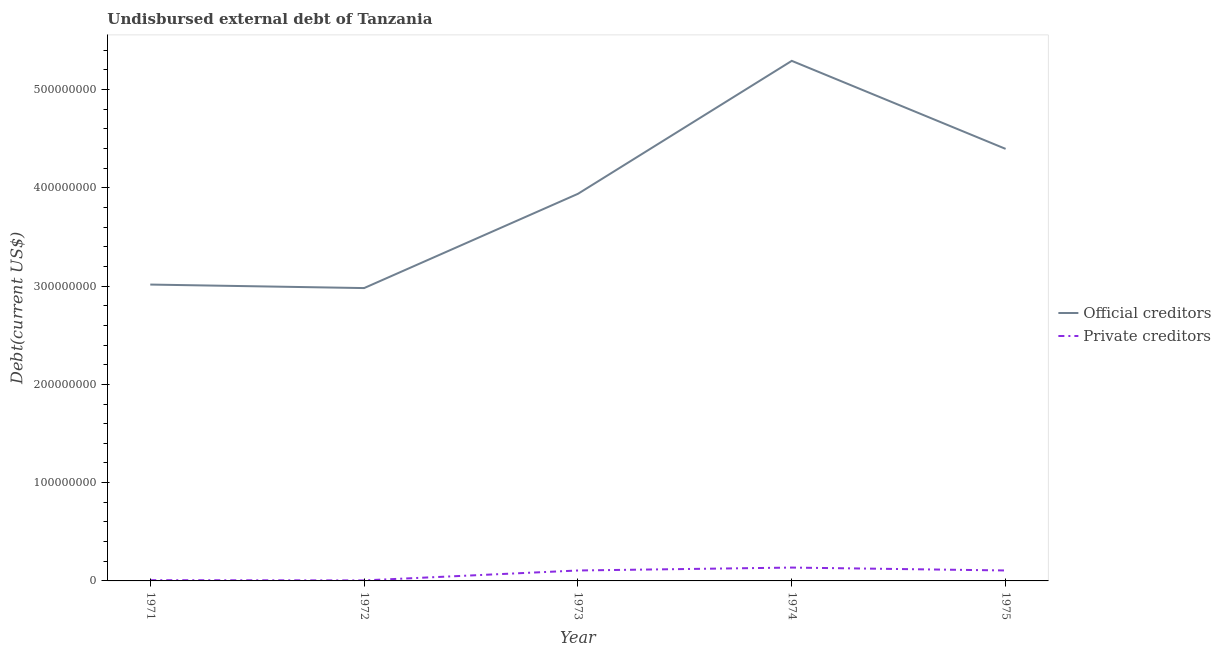How many different coloured lines are there?
Keep it short and to the point. 2. Does the line corresponding to undisbursed external debt of official creditors intersect with the line corresponding to undisbursed external debt of private creditors?
Your answer should be very brief. No. Is the number of lines equal to the number of legend labels?
Your response must be concise. Yes. What is the undisbursed external debt of official creditors in 1973?
Keep it short and to the point. 3.94e+08. Across all years, what is the maximum undisbursed external debt of official creditors?
Keep it short and to the point. 5.29e+08. Across all years, what is the minimum undisbursed external debt of private creditors?
Your answer should be very brief. 5.15e+05. In which year was the undisbursed external debt of private creditors maximum?
Provide a succinct answer. 1974. In which year was the undisbursed external debt of private creditors minimum?
Give a very brief answer. 1972. What is the total undisbursed external debt of official creditors in the graph?
Provide a short and direct response. 1.96e+09. What is the difference between the undisbursed external debt of private creditors in 1972 and that in 1973?
Ensure brevity in your answer.  -1.01e+07. What is the difference between the undisbursed external debt of official creditors in 1975 and the undisbursed external debt of private creditors in 1972?
Your response must be concise. 4.39e+08. What is the average undisbursed external debt of official creditors per year?
Your answer should be very brief. 3.92e+08. In the year 1972, what is the difference between the undisbursed external debt of official creditors and undisbursed external debt of private creditors?
Offer a terse response. 2.97e+08. In how many years, is the undisbursed external debt of private creditors greater than 340000000 US$?
Offer a terse response. 0. What is the ratio of the undisbursed external debt of official creditors in 1974 to that in 1975?
Provide a short and direct response. 1.2. Is the undisbursed external debt of official creditors in 1971 less than that in 1975?
Make the answer very short. Yes. Is the difference between the undisbursed external debt of official creditors in 1971 and 1975 greater than the difference between the undisbursed external debt of private creditors in 1971 and 1975?
Ensure brevity in your answer.  No. What is the difference between the highest and the second highest undisbursed external debt of official creditors?
Keep it short and to the point. 8.96e+07. What is the difference between the highest and the lowest undisbursed external debt of official creditors?
Your answer should be compact. 2.31e+08. Does the undisbursed external debt of official creditors monotonically increase over the years?
Make the answer very short. No. Is the undisbursed external debt of private creditors strictly less than the undisbursed external debt of official creditors over the years?
Your answer should be compact. Yes. How many years are there in the graph?
Your answer should be very brief. 5. What is the difference between two consecutive major ticks on the Y-axis?
Your answer should be very brief. 1.00e+08. Are the values on the major ticks of Y-axis written in scientific E-notation?
Give a very brief answer. No. Does the graph contain any zero values?
Provide a short and direct response. No. How many legend labels are there?
Ensure brevity in your answer.  2. What is the title of the graph?
Keep it short and to the point. Undisbursed external debt of Tanzania. What is the label or title of the X-axis?
Provide a short and direct response. Year. What is the label or title of the Y-axis?
Your answer should be compact. Debt(current US$). What is the Debt(current US$) in Official creditors in 1971?
Your answer should be compact. 3.02e+08. What is the Debt(current US$) of Private creditors in 1971?
Your answer should be compact. 7.65e+05. What is the Debt(current US$) of Official creditors in 1972?
Offer a terse response. 2.98e+08. What is the Debt(current US$) in Private creditors in 1972?
Provide a succinct answer. 5.15e+05. What is the Debt(current US$) of Official creditors in 1973?
Your answer should be very brief. 3.94e+08. What is the Debt(current US$) in Private creditors in 1973?
Offer a very short reply. 1.06e+07. What is the Debt(current US$) in Official creditors in 1974?
Make the answer very short. 5.29e+08. What is the Debt(current US$) of Private creditors in 1974?
Ensure brevity in your answer.  1.36e+07. What is the Debt(current US$) in Official creditors in 1975?
Your answer should be compact. 4.40e+08. What is the Debt(current US$) of Private creditors in 1975?
Offer a terse response. 1.06e+07. Across all years, what is the maximum Debt(current US$) of Official creditors?
Keep it short and to the point. 5.29e+08. Across all years, what is the maximum Debt(current US$) in Private creditors?
Make the answer very short. 1.36e+07. Across all years, what is the minimum Debt(current US$) of Official creditors?
Your answer should be very brief. 2.98e+08. Across all years, what is the minimum Debt(current US$) of Private creditors?
Your answer should be very brief. 5.15e+05. What is the total Debt(current US$) in Official creditors in the graph?
Your response must be concise. 1.96e+09. What is the total Debt(current US$) in Private creditors in the graph?
Offer a terse response. 3.61e+07. What is the difference between the Debt(current US$) in Official creditors in 1971 and that in 1972?
Provide a short and direct response. 3.57e+06. What is the difference between the Debt(current US$) in Private creditors in 1971 and that in 1972?
Your answer should be very brief. 2.50e+05. What is the difference between the Debt(current US$) of Official creditors in 1971 and that in 1973?
Provide a short and direct response. -9.23e+07. What is the difference between the Debt(current US$) of Private creditors in 1971 and that in 1973?
Offer a terse response. -9.85e+06. What is the difference between the Debt(current US$) in Official creditors in 1971 and that in 1974?
Your answer should be compact. -2.28e+08. What is the difference between the Debt(current US$) of Private creditors in 1971 and that in 1974?
Your response must be concise. -1.28e+07. What is the difference between the Debt(current US$) of Official creditors in 1971 and that in 1975?
Keep it short and to the point. -1.38e+08. What is the difference between the Debt(current US$) in Private creditors in 1971 and that in 1975?
Your answer should be very brief. -9.87e+06. What is the difference between the Debt(current US$) in Official creditors in 1972 and that in 1973?
Offer a terse response. -9.59e+07. What is the difference between the Debt(current US$) of Private creditors in 1972 and that in 1973?
Offer a very short reply. -1.01e+07. What is the difference between the Debt(current US$) of Official creditors in 1972 and that in 1974?
Keep it short and to the point. -2.31e+08. What is the difference between the Debt(current US$) in Private creditors in 1972 and that in 1974?
Make the answer very short. -1.31e+07. What is the difference between the Debt(current US$) in Official creditors in 1972 and that in 1975?
Offer a terse response. -1.42e+08. What is the difference between the Debt(current US$) in Private creditors in 1972 and that in 1975?
Keep it short and to the point. -1.01e+07. What is the difference between the Debt(current US$) of Official creditors in 1973 and that in 1974?
Provide a succinct answer. -1.35e+08. What is the difference between the Debt(current US$) of Private creditors in 1973 and that in 1974?
Keep it short and to the point. -2.97e+06. What is the difference between the Debt(current US$) of Official creditors in 1973 and that in 1975?
Keep it short and to the point. -4.57e+07. What is the difference between the Debt(current US$) in Private creditors in 1973 and that in 1975?
Give a very brief answer. -2.10e+04. What is the difference between the Debt(current US$) in Official creditors in 1974 and that in 1975?
Keep it short and to the point. 8.96e+07. What is the difference between the Debt(current US$) in Private creditors in 1974 and that in 1975?
Give a very brief answer. 2.95e+06. What is the difference between the Debt(current US$) in Official creditors in 1971 and the Debt(current US$) in Private creditors in 1972?
Your response must be concise. 3.01e+08. What is the difference between the Debt(current US$) in Official creditors in 1971 and the Debt(current US$) in Private creditors in 1973?
Your answer should be compact. 2.91e+08. What is the difference between the Debt(current US$) in Official creditors in 1971 and the Debt(current US$) in Private creditors in 1974?
Provide a succinct answer. 2.88e+08. What is the difference between the Debt(current US$) in Official creditors in 1971 and the Debt(current US$) in Private creditors in 1975?
Your response must be concise. 2.91e+08. What is the difference between the Debt(current US$) of Official creditors in 1972 and the Debt(current US$) of Private creditors in 1973?
Ensure brevity in your answer.  2.87e+08. What is the difference between the Debt(current US$) of Official creditors in 1972 and the Debt(current US$) of Private creditors in 1974?
Provide a succinct answer. 2.84e+08. What is the difference between the Debt(current US$) in Official creditors in 1972 and the Debt(current US$) in Private creditors in 1975?
Make the answer very short. 2.87e+08. What is the difference between the Debt(current US$) in Official creditors in 1973 and the Debt(current US$) in Private creditors in 1974?
Keep it short and to the point. 3.80e+08. What is the difference between the Debt(current US$) in Official creditors in 1973 and the Debt(current US$) in Private creditors in 1975?
Your answer should be very brief. 3.83e+08. What is the difference between the Debt(current US$) in Official creditors in 1974 and the Debt(current US$) in Private creditors in 1975?
Your response must be concise. 5.19e+08. What is the average Debt(current US$) of Official creditors per year?
Give a very brief answer. 3.92e+08. What is the average Debt(current US$) in Private creditors per year?
Make the answer very short. 7.22e+06. In the year 1971, what is the difference between the Debt(current US$) of Official creditors and Debt(current US$) of Private creditors?
Provide a short and direct response. 3.01e+08. In the year 1972, what is the difference between the Debt(current US$) in Official creditors and Debt(current US$) in Private creditors?
Offer a very short reply. 2.97e+08. In the year 1973, what is the difference between the Debt(current US$) of Official creditors and Debt(current US$) of Private creditors?
Make the answer very short. 3.83e+08. In the year 1974, what is the difference between the Debt(current US$) in Official creditors and Debt(current US$) in Private creditors?
Offer a terse response. 5.16e+08. In the year 1975, what is the difference between the Debt(current US$) of Official creditors and Debt(current US$) of Private creditors?
Your response must be concise. 4.29e+08. What is the ratio of the Debt(current US$) in Official creditors in 1971 to that in 1972?
Your answer should be compact. 1.01. What is the ratio of the Debt(current US$) in Private creditors in 1971 to that in 1972?
Provide a short and direct response. 1.49. What is the ratio of the Debt(current US$) in Official creditors in 1971 to that in 1973?
Make the answer very short. 0.77. What is the ratio of the Debt(current US$) in Private creditors in 1971 to that in 1973?
Your answer should be compact. 0.07. What is the ratio of the Debt(current US$) in Official creditors in 1971 to that in 1974?
Your response must be concise. 0.57. What is the ratio of the Debt(current US$) in Private creditors in 1971 to that in 1974?
Provide a short and direct response. 0.06. What is the ratio of the Debt(current US$) in Official creditors in 1971 to that in 1975?
Ensure brevity in your answer.  0.69. What is the ratio of the Debt(current US$) of Private creditors in 1971 to that in 1975?
Your answer should be very brief. 0.07. What is the ratio of the Debt(current US$) in Official creditors in 1972 to that in 1973?
Your answer should be compact. 0.76. What is the ratio of the Debt(current US$) of Private creditors in 1972 to that in 1973?
Offer a terse response. 0.05. What is the ratio of the Debt(current US$) in Official creditors in 1972 to that in 1974?
Your answer should be compact. 0.56. What is the ratio of the Debt(current US$) of Private creditors in 1972 to that in 1974?
Give a very brief answer. 0.04. What is the ratio of the Debt(current US$) in Official creditors in 1972 to that in 1975?
Provide a succinct answer. 0.68. What is the ratio of the Debt(current US$) in Private creditors in 1972 to that in 1975?
Provide a succinct answer. 0.05. What is the ratio of the Debt(current US$) of Official creditors in 1973 to that in 1974?
Provide a succinct answer. 0.74. What is the ratio of the Debt(current US$) of Private creditors in 1973 to that in 1974?
Provide a short and direct response. 0.78. What is the ratio of the Debt(current US$) in Official creditors in 1973 to that in 1975?
Your answer should be compact. 0.9. What is the ratio of the Debt(current US$) in Private creditors in 1973 to that in 1975?
Give a very brief answer. 1. What is the ratio of the Debt(current US$) in Official creditors in 1974 to that in 1975?
Your answer should be compact. 1.2. What is the ratio of the Debt(current US$) in Private creditors in 1974 to that in 1975?
Give a very brief answer. 1.28. What is the difference between the highest and the second highest Debt(current US$) of Official creditors?
Ensure brevity in your answer.  8.96e+07. What is the difference between the highest and the second highest Debt(current US$) of Private creditors?
Your response must be concise. 2.95e+06. What is the difference between the highest and the lowest Debt(current US$) of Official creditors?
Provide a succinct answer. 2.31e+08. What is the difference between the highest and the lowest Debt(current US$) of Private creditors?
Give a very brief answer. 1.31e+07. 